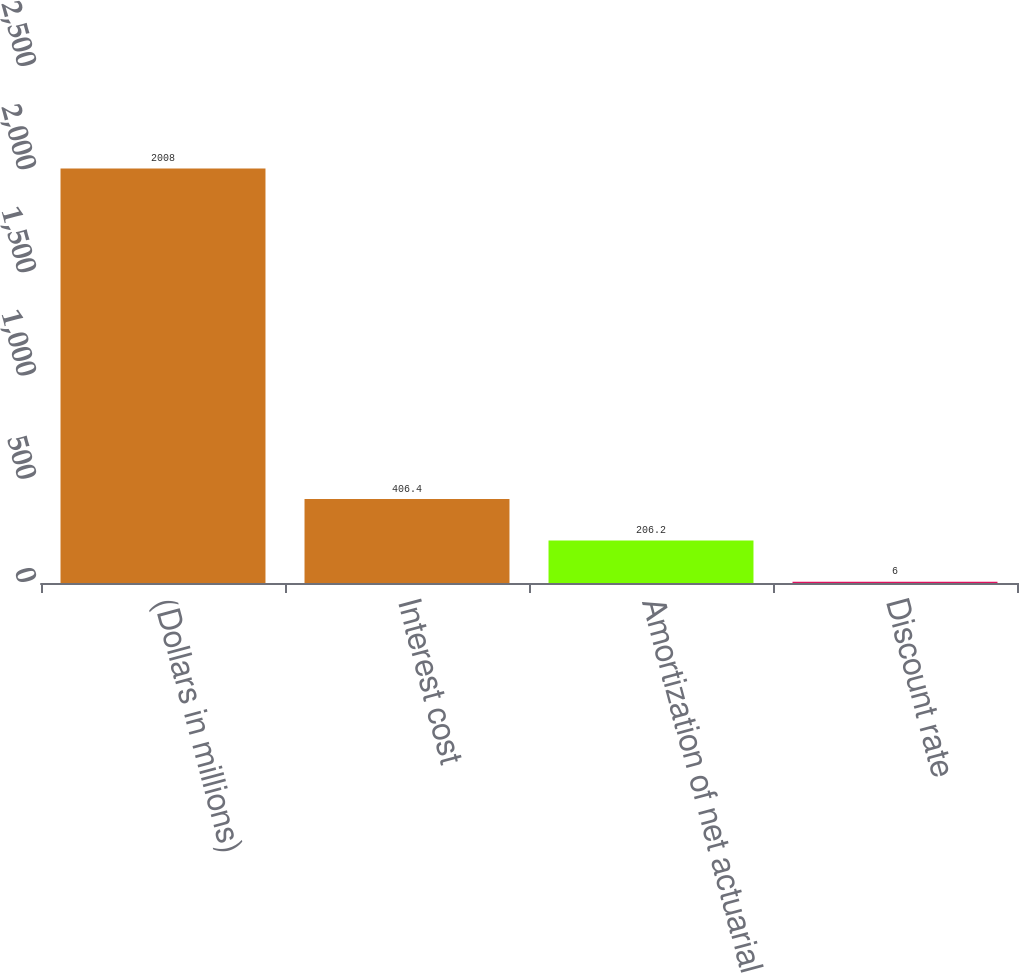<chart> <loc_0><loc_0><loc_500><loc_500><bar_chart><fcel>(Dollars in millions)<fcel>Interest cost<fcel>Amortization of net actuarial<fcel>Discount rate<nl><fcel>2008<fcel>406.4<fcel>206.2<fcel>6<nl></chart> 